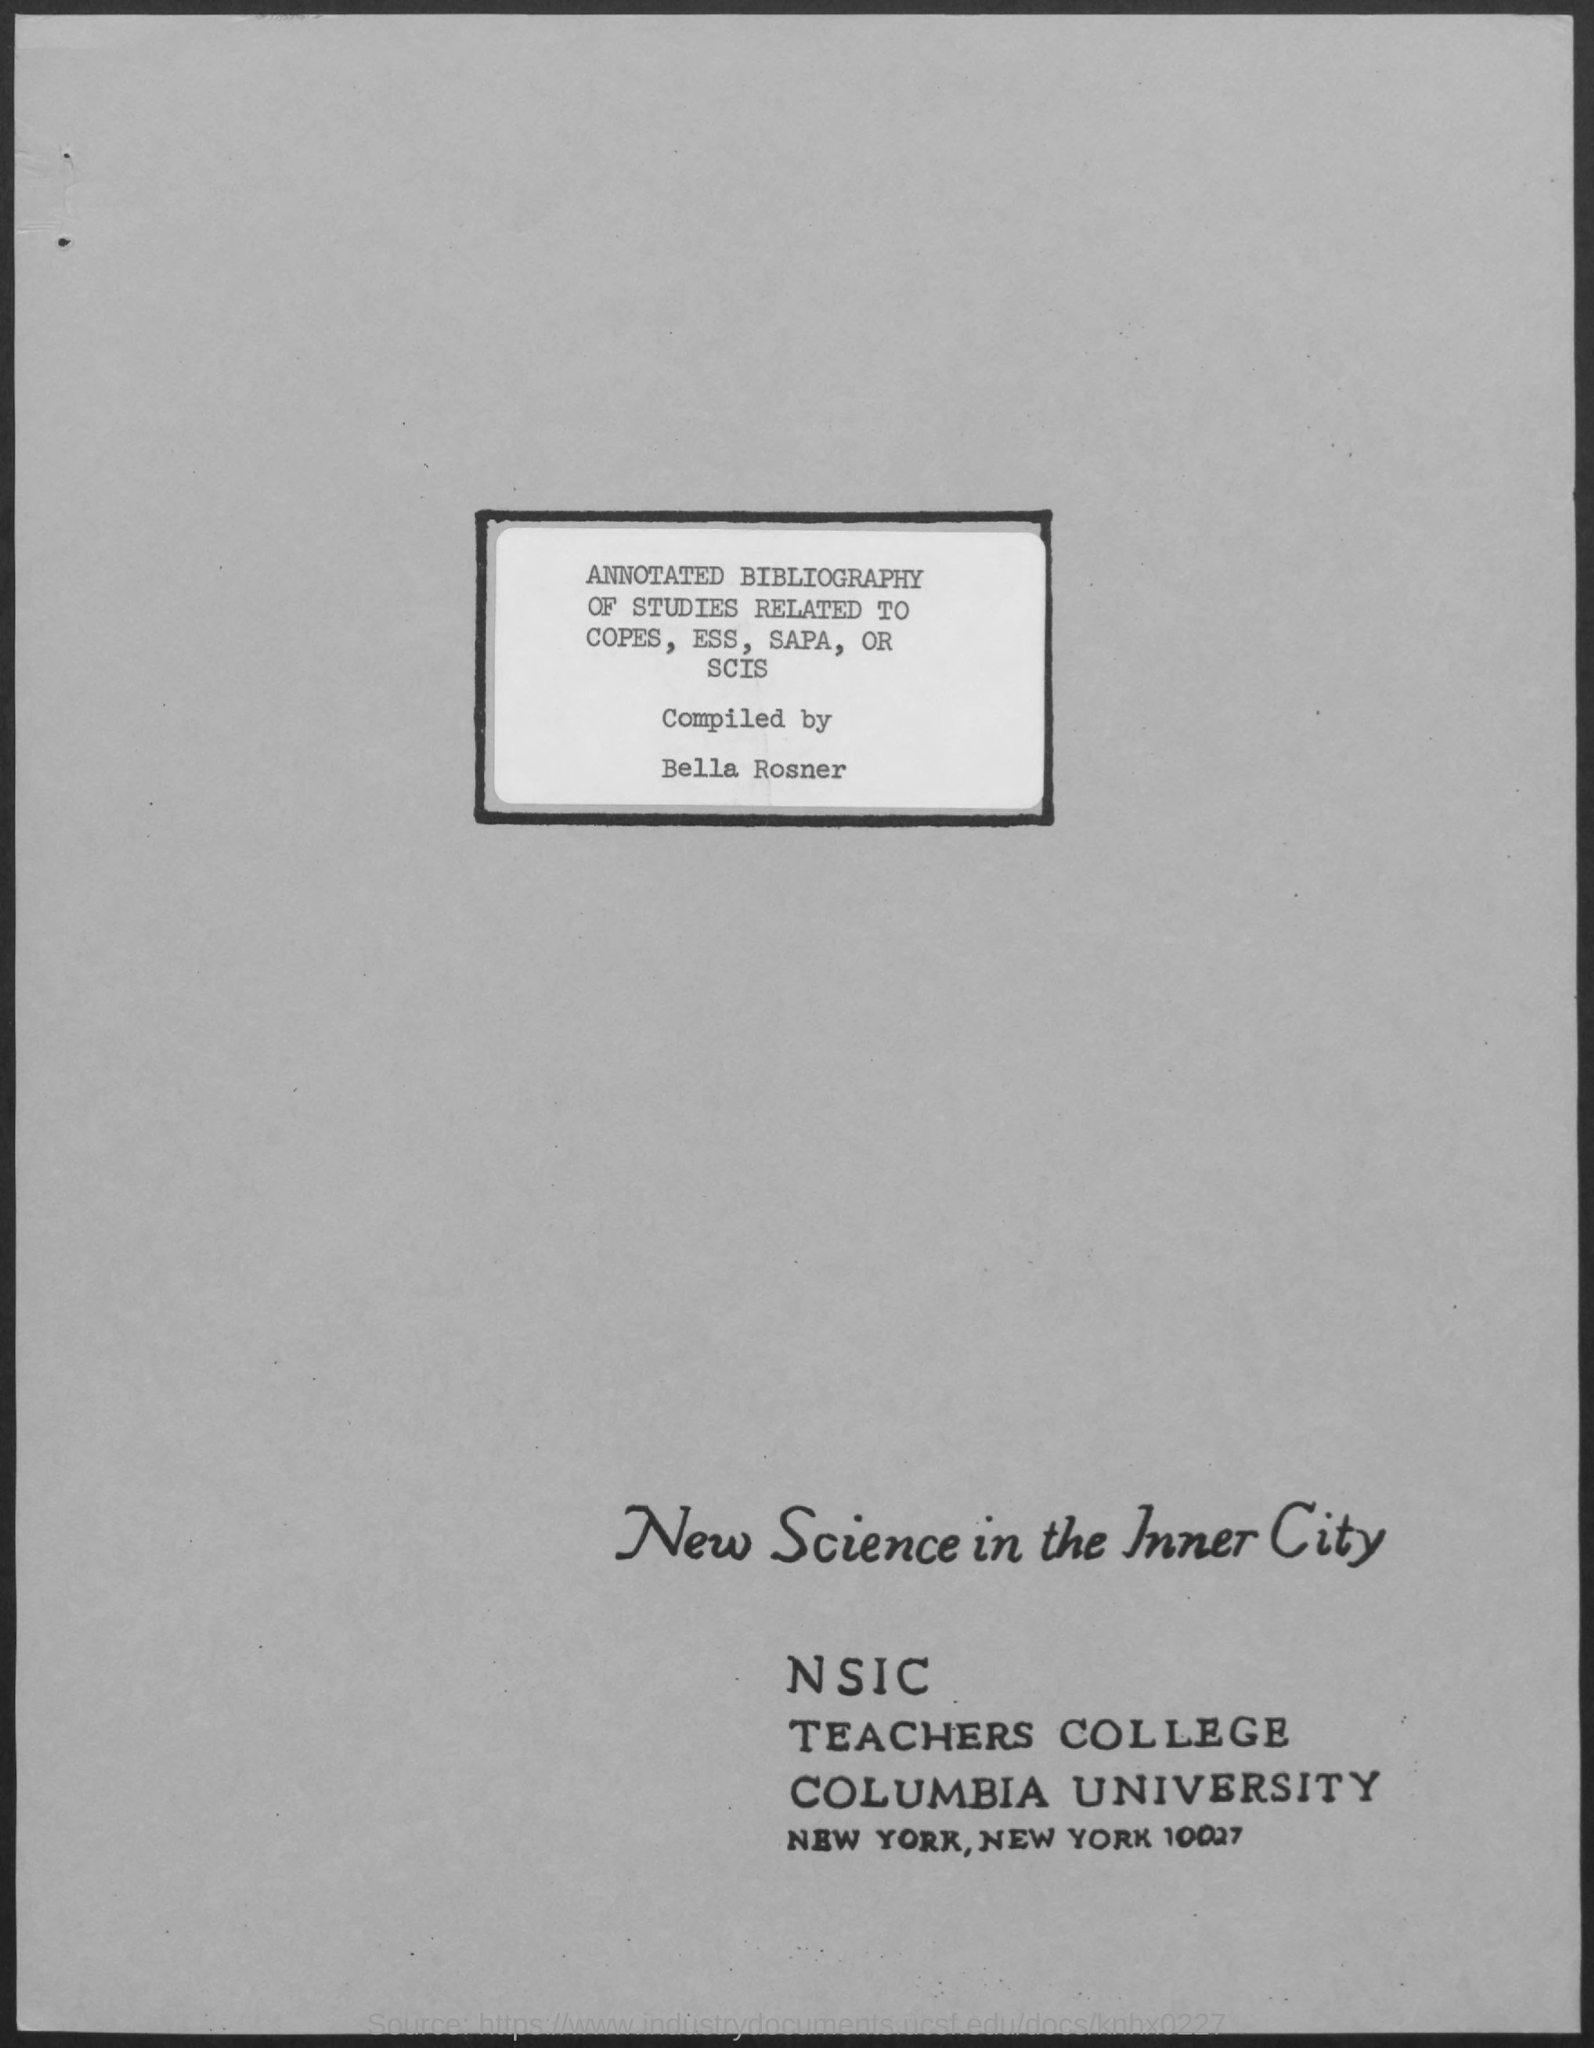List a handful of essential elements in this visual. What does NSIC stand for? It stands for New Science in the Inner City. Bella Rosner compiled the annotated bibliography. 